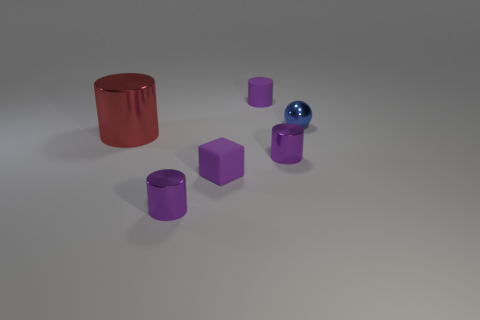What number of other things are there of the same color as the large cylinder?
Make the answer very short. 0. Do the purple cylinder behind the large red cylinder and the matte thing in front of the rubber cylinder have the same size?
Provide a short and direct response. Yes. Is the ball made of the same material as the cylinder in front of the tiny rubber block?
Offer a very short reply. Yes. Are there more shiny cylinders in front of the small matte cube than tiny blue things behind the blue thing?
Offer a terse response. Yes. There is a small cylinder left of the purple cylinder that is behind the tiny blue metallic object; what color is it?
Your answer should be compact. Purple. What number of spheres are tiny red objects or red shiny objects?
Ensure brevity in your answer.  0. What number of objects are both in front of the small purple rubber cylinder and behind the big thing?
Offer a very short reply. 1. What color is the cylinder that is right of the rubber cylinder?
Provide a succinct answer. Purple. The red cylinder that is the same material as the small blue object is what size?
Give a very brief answer. Large. How many rubber objects are in front of the purple cylinder behind the metallic sphere?
Ensure brevity in your answer.  1. 